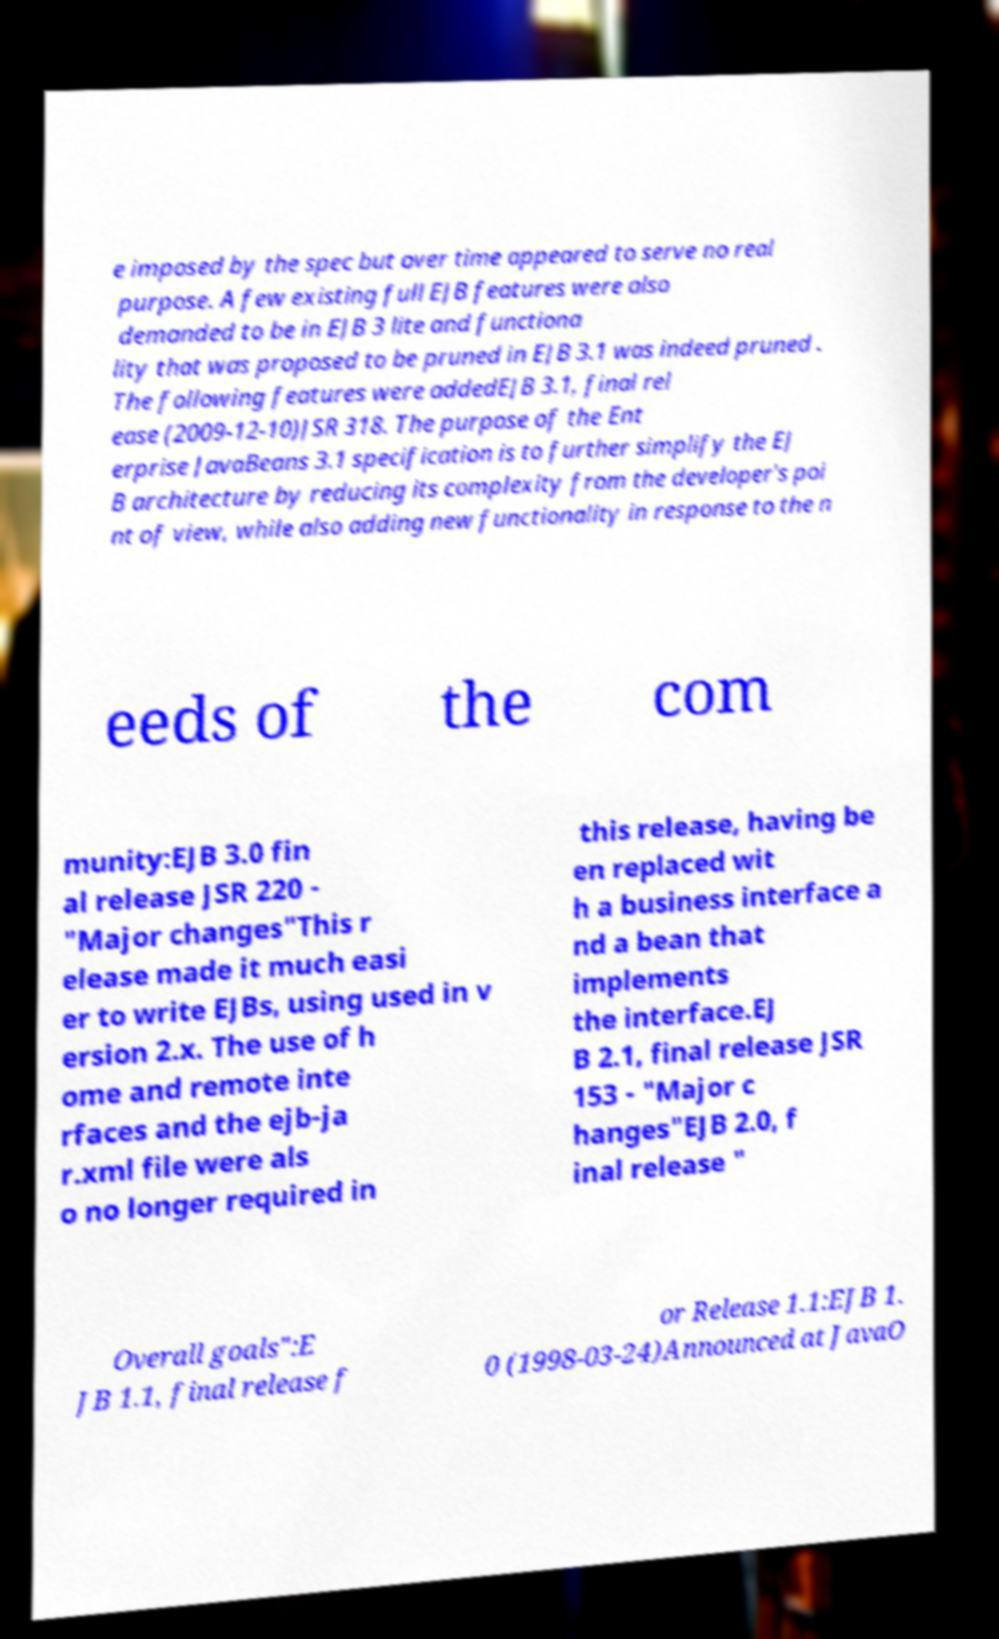What messages or text are displayed in this image? I need them in a readable, typed format. e imposed by the spec but over time appeared to serve no real purpose. A few existing full EJB features were also demanded to be in EJB 3 lite and functiona lity that was proposed to be pruned in EJB 3.1 was indeed pruned . The following features were addedEJB 3.1, final rel ease (2009-12-10)JSR 318. The purpose of the Ent erprise JavaBeans 3.1 specification is to further simplify the EJ B architecture by reducing its complexity from the developer's poi nt of view, while also adding new functionality in response to the n eeds of the com munity:EJB 3.0 fin al release JSR 220 - "Major changes"This r elease made it much easi er to write EJBs, using used in v ersion 2.x. The use of h ome and remote inte rfaces and the ejb-ja r.xml file were als o no longer required in this release, having be en replaced wit h a business interface a nd a bean that implements the interface.EJ B 2.1, final release JSR 153 - "Major c hanges"EJB 2.0, f inal release " Overall goals":E JB 1.1, final release f or Release 1.1:EJB 1. 0 (1998-03-24)Announced at JavaO 